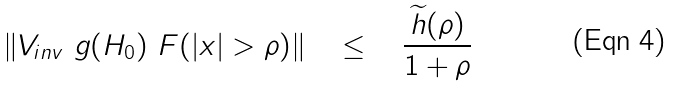Convert formula to latex. <formula><loc_0><loc_0><loc_500><loc_500>\| V _ { i n v } \ g ( H _ { 0 } ) \ F ( | x | > \rho ) \| \quad \leq \quad \frac { \widetilde { h } ( \rho ) } { 1 + \rho }</formula> 